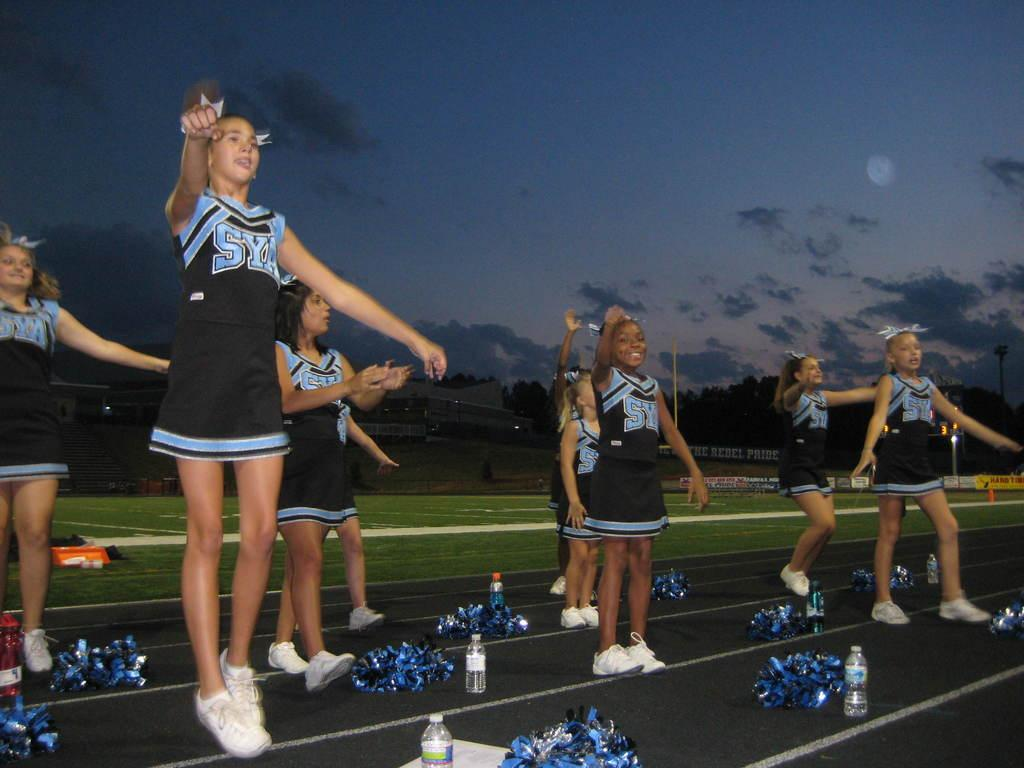<image>
Provide a brief description of the given image. A group of cheerleaders from SYA are jumping in place. 